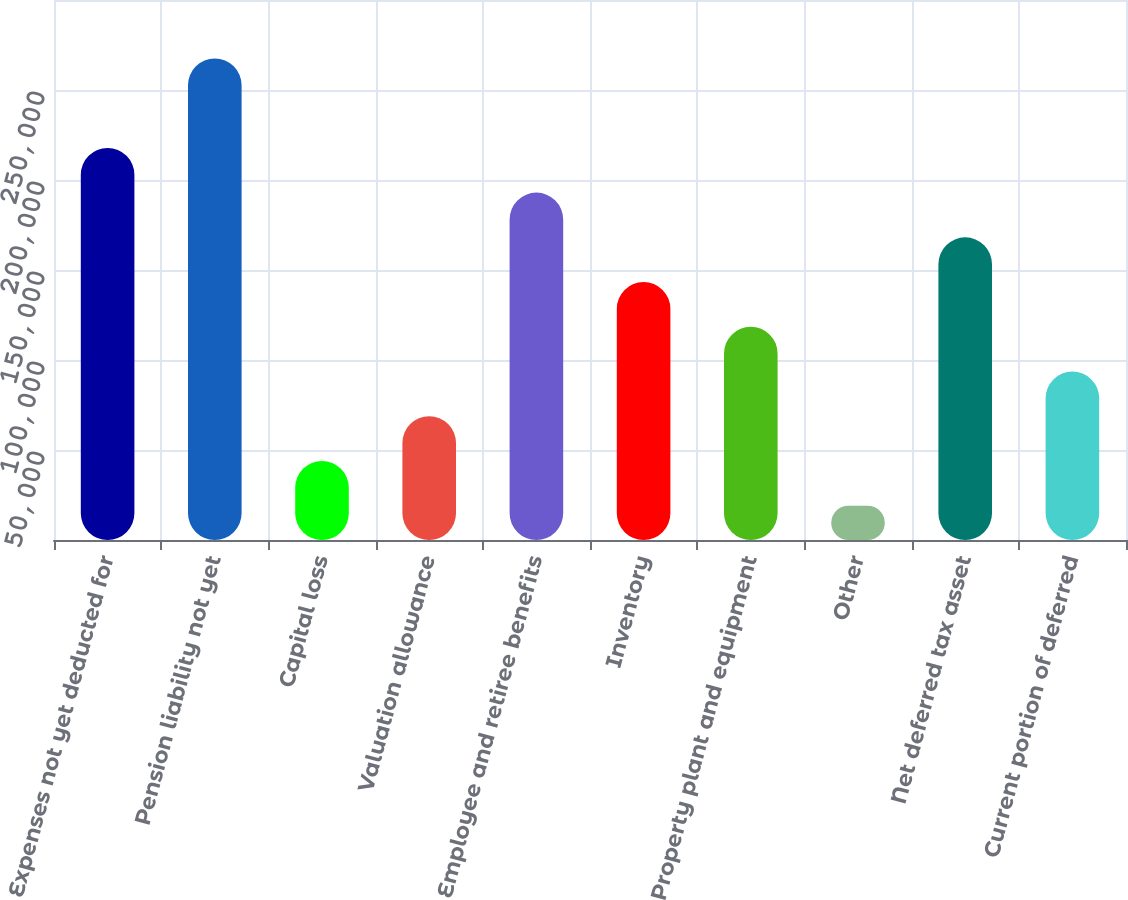Convert chart. <chart><loc_0><loc_0><loc_500><loc_500><bar_chart><fcel>Expenses not yet deducted for<fcel>Pension liability not yet<fcel>Capital loss<fcel>Valuation allowance<fcel>Employee and retiree benefits<fcel>Inventory<fcel>Property plant and equipment<fcel>Other<fcel>Net deferred tax asset<fcel>Current portion of deferred<nl><fcel>217845<fcel>267544<fcel>43896.7<fcel>68746.4<fcel>192995<fcel>143296<fcel>118446<fcel>19047<fcel>168145<fcel>93596.1<nl></chart> 